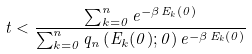Convert formula to latex. <formula><loc_0><loc_0><loc_500><loc_500>t < \frac { \sum _ { k = 0 } ^ { n } e ^ { - \beta \, E _ { k } ( 0 ) } } { \sum _ { k = 0 } ^ { n } q _ { n } \left ( E _ { k } ( 0 ) ; 0 \right ) e ^ { - \beta \, E _ { k } ( 0 ) } }</formula> 